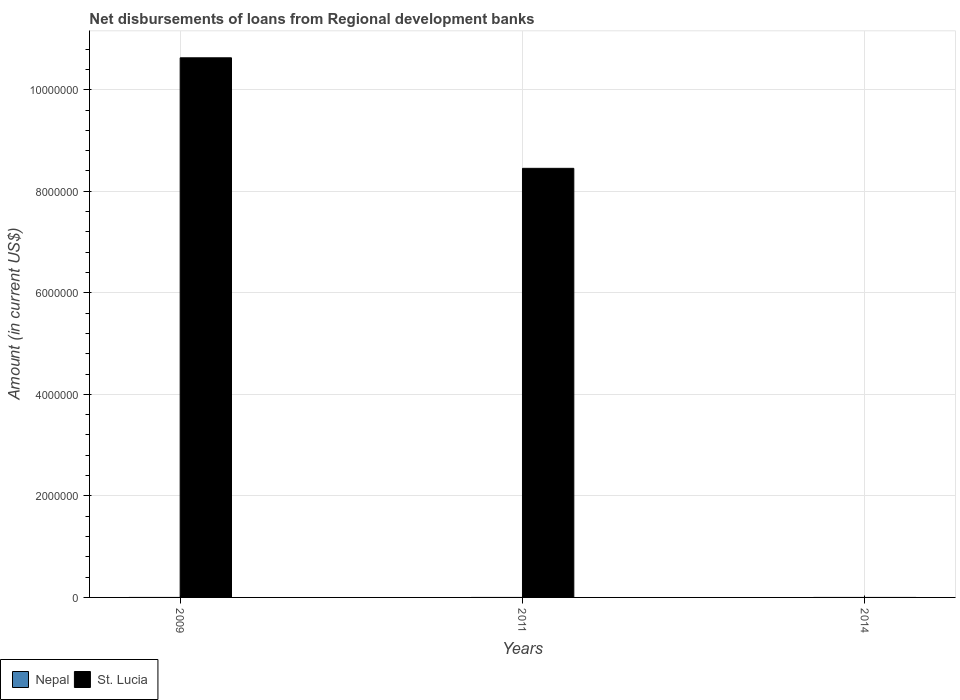How many different coloured bars are there?
Give a very brief answer. 1. How many bars are there on the 2nd tick from the left?
Provide a succinct answer. 1. How many bars are there on the 3rd tick from the right?
Offer a terse response. 1. What is the label of the 3rd group of bars from the left?
Keep it short and to the point. 2014. What is the amount of disbursements of loans from regional development banks in Nepal in 2011?
Your answer should be very brief. 0. Across all years, what is the maximum amount of disbursements of loans from regional development banks in St. Lucia?
Offer a very short reply. 1.06e+07. What is the total amount of disbursements of loans from regional development banks in Nepal in the graph?
Provide a short and direct response. 0. What is the difference between the amount of disbursements of loans from regional development banks in St. Lucia in 2009 and that in 2011?
Make the answer very short. 2.18e+06. What is the difference between the amount of disbursements of loans from regional development banks in Nepal in 2011 and the amount of disbursements of loans from regional development banks in St. Lucia in 2009?
Offer a very short reply. -1.06e+07. What is the average amount of disbursements of loans from regional development banks in Nepal per year?
Your answer should be very brief. 0. In how many years, is the amount of disbursements of loans from regional development banks in Nepal greater than 6000000 US$?
Your answer should be very brief. 0. What is the difference between the highest and the lowest amount of disbursements of loans from regional development banks in St. Lucia?
Provide a short and direct response. 1.06e+07. How many bars are there?
Your answer should be very brief. 2. What is the difference between two consecutive major ticks on the Y-axis?
Offer a very short reply. 2.00e+06. Are the values on the major ticks of Y-axis written in scientific E-notation?
Make the answer very short. No. Does the graph contain any zero values?
Your answer should be compact. Yes. Does the graph contain grids?
Your answer should be compact. Yes. How many legend labels are there?
Provide a succinct answer. 2. What is the title of the graph?
Your response must be concise. Net disbursements of loans from Regional development banks. Does "Trinidad and Tobago" appear as one of the legend labels in the graph?
Keep it short and to the point. No. What is the Amount (in current US$) in Nepal in 2009?
Offer a terse response. 0. What is the Amount (in current US$) in St. Lucia in 2009?
Your answer should be compact. 1.06e+07. What is the Amount (in current US$) of Nepal in 2011?
Give a very brief answer. 0. What is the Amount (in current US$) of St. Lucia in 2011?
Offer a very short reply. 8.45e+06. What is the Amount (in current US$) of Nepal in 2014?
Provide a succinct answer. 0. What is the Amount (in current US$) in St. Lucia in 2014?
Provide a succinct answer. 0. Across all years, what is the maximum Amount (in current US$) in St. Lucia?
Provide a succinct answer. 1.06e+07. Across all years, what is the minimum Amount (in current US$) of St. Lucia?
Give a very brief answer. 0. What is the total Amount (in current US$) in St. Lucia in the graph?
Ensure brevity in your answer.  1.91e+07. What is the difference between the Amount (in current US$) of St. Lucia in 2009 and that in 2011?
Provide a short and direct response. 2.18e+06. What is the average Amount (in current US$) of St. Lucia per year?
Provide a short and direct response. 6.36e+06. What is the ratio of the Amount (in current US$) of St. Lucia in 2009 to that in 2011?
Make the answer very short. 1.26. What is the difference between the highest and the lowest Amount (in current US$) in St. Lucia?
Give a very brief answer. 1.06e+07. 